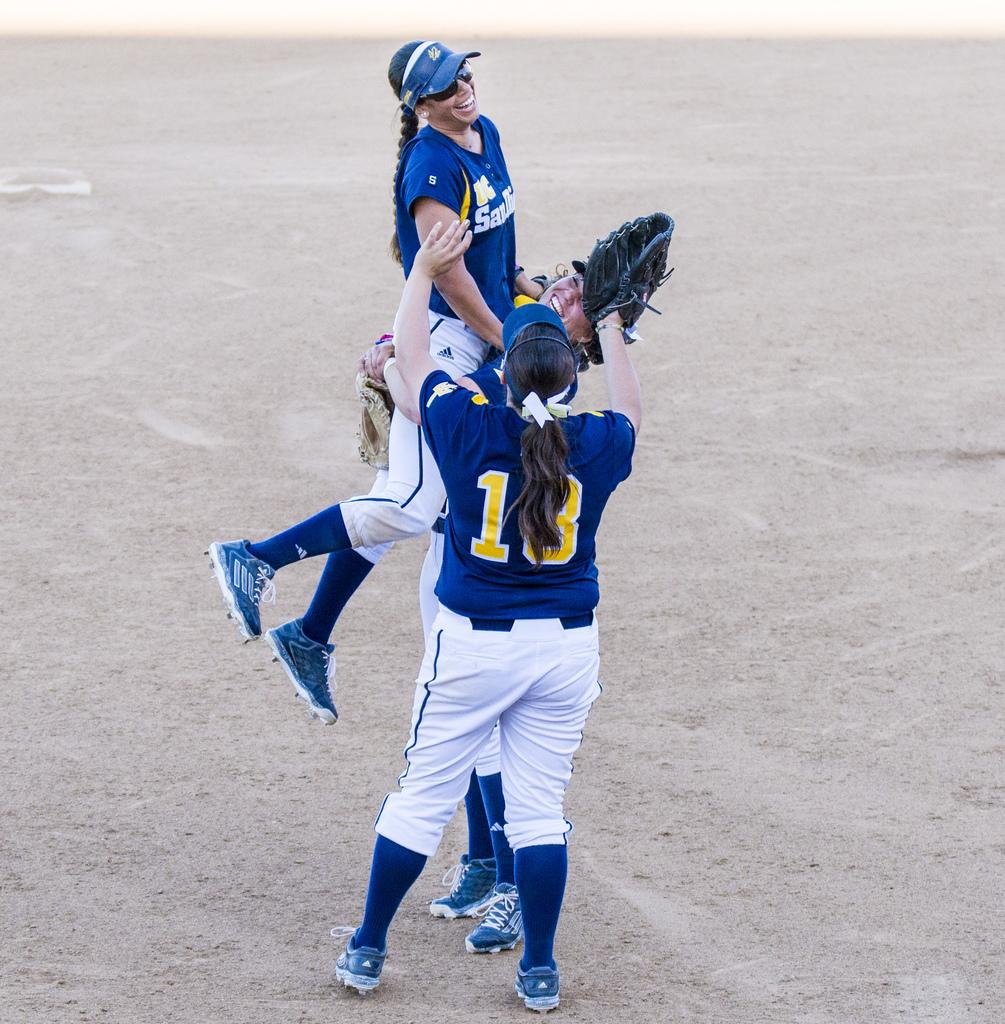<image>
Render a clear and concise summary of the photo. a base ball player with a SAN jersey jumping into the arms of other players 